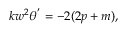Convert formula to latex. <formula><loc_0><loc_0><loc_500><loc_500>\begin{array} { r } { k w ^ { 2 } \theta ^ { ^ { \prime } } = - 2 ( 2 p + m ) , } \end{array}</formula> 